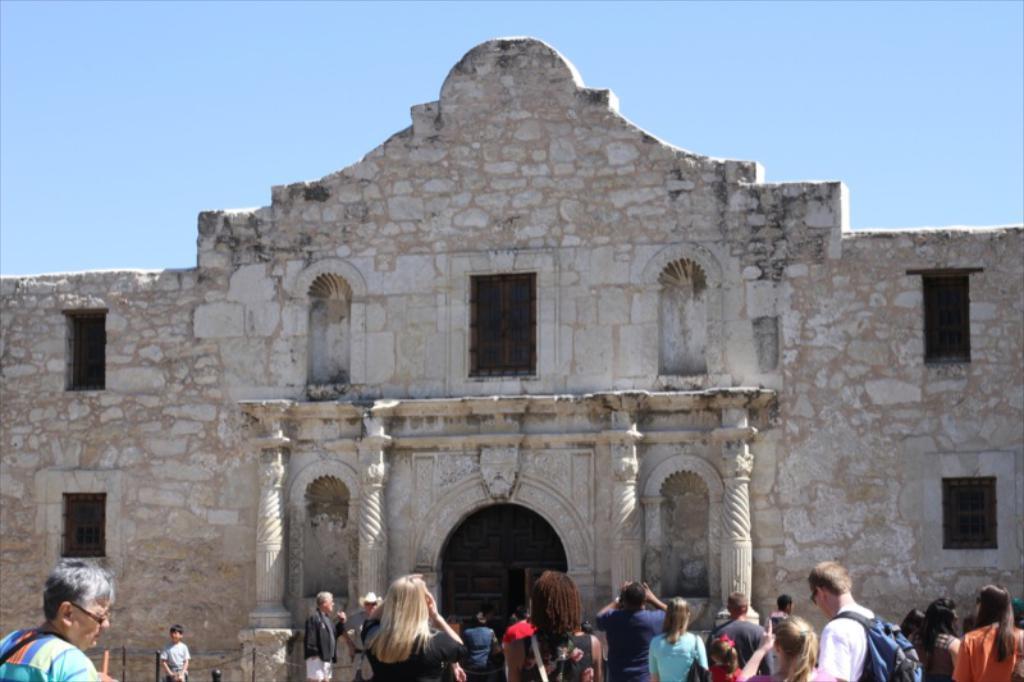Can you describe this image briefly? At the bottom of the image there are people. In the background of the image there is a stone structure with windows, door, pillars. At the top of the image there is sky. 